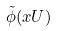<formula> <loc_0><loc_0><loc_500><loc_500>\tilde { \phi } ( x U )</formula> 